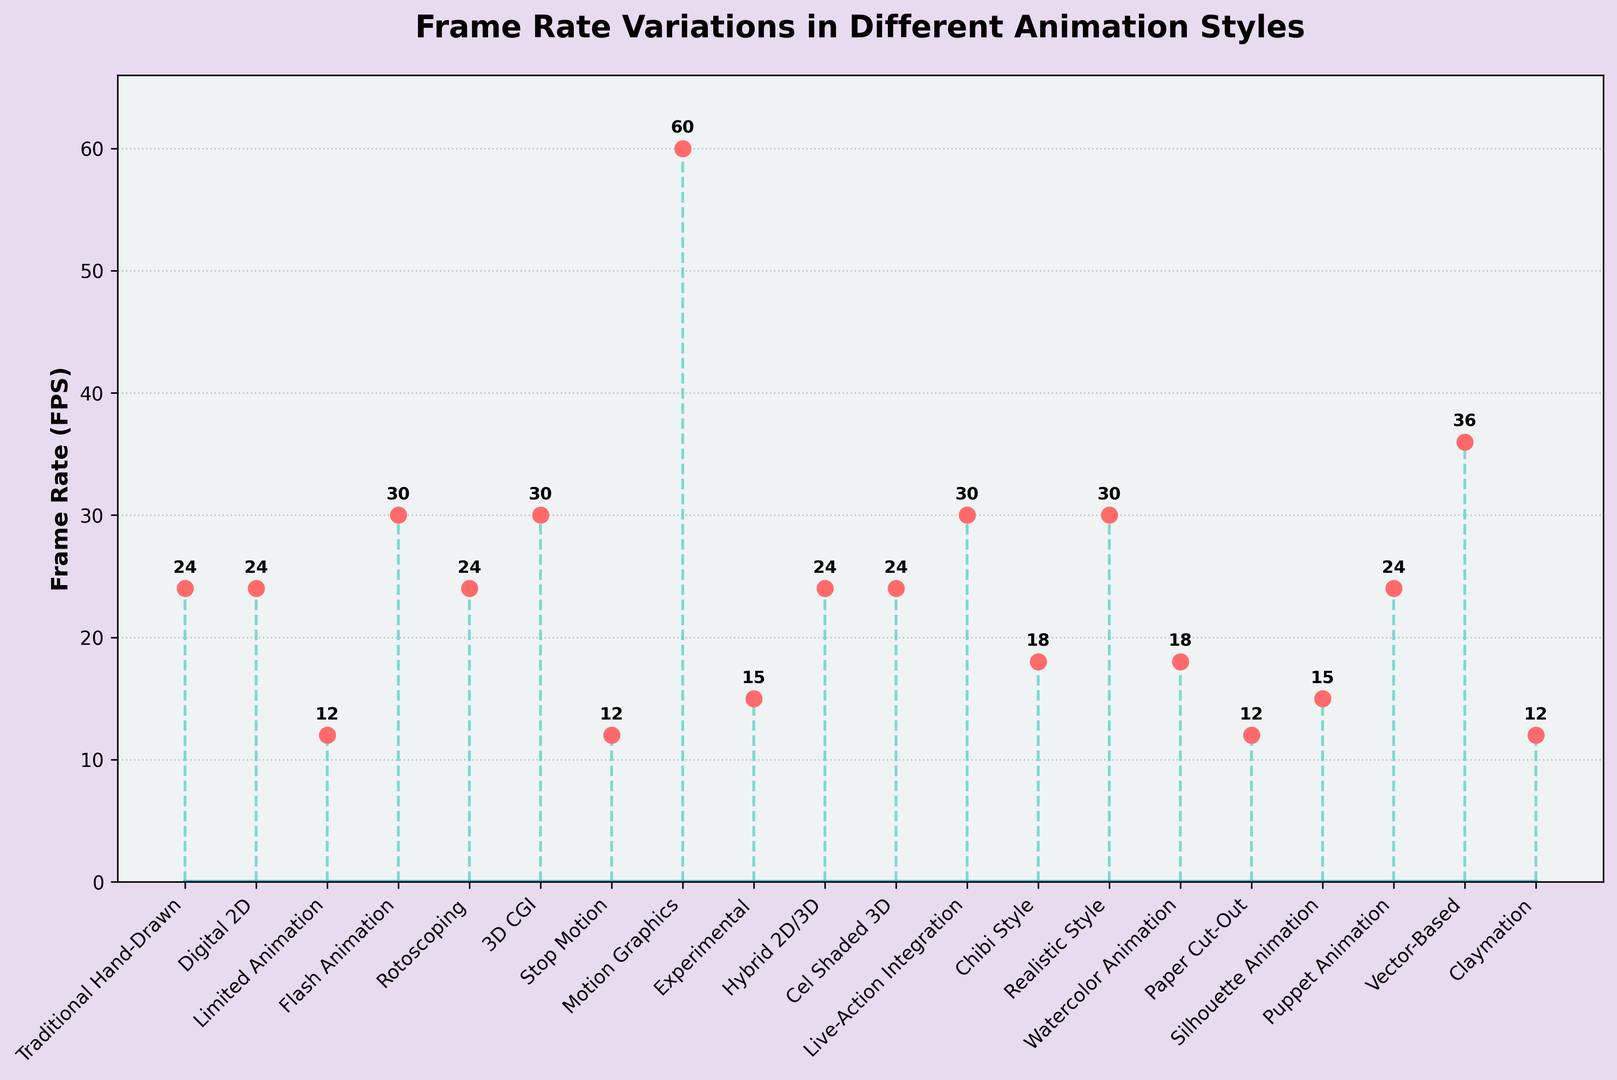What animation style has the highest frame rate? To determine the highest frame rate, observe the tallest stem in the plot that reaches the highest value on the y-axis. The style labeled "Motion Graphics" reaches 60 FPS.
Answer: Motion Graphics Which animation styles have a frame rate of 30 FPS? Look for stems that reach the 30 FPS mark on the y-axis. The labels at these points are "Flash Animation", "3D CGI", "Live-Action Integration", and "Realistic Style".
Answer: Flash Animation, 3D CGI, Live-Action Integration, Realistic Style How many animation styles have a frame rate less than 20 FPS? Count the number of stems that do not reach the 20 FPS mark on the y-axis. The styles are "Limited Animation" (12 FPS), "Stop Motion" (12 FPS), "Paper Cut-Out" (12 FPS), "Claymation" (12 FPS), "Experimental" (15 FPS), and "Silhouette Animation" (15 FPS). There are 6 in total.
Answer: 6 What is the difference in frame rate between "Vector-Based" and "Chibi Style"? The frame rate of "Vector-Based" is 36 FPS and "Chibi Style" is 18 FPS. The difference is calculated as 36 - 18 = 18 FPS.
Answer: 18 FPS What is the average frame rate of traditional and digital 2D animation styles (Traditional Hand-Drawn and Digital 2D)? Both styles have a frame rate of 24 FPS. The average is calculated as (24 + 24) / 2 = 24 FPS.
Answer: 24 FPS Which animation style is represented by the darkest stem lines in the plot? The stems are visually unified by color so this question is not applicable, but if we interpret "darkest" as "most visually emphasized", we would appreciate the lengths of the stems because the highest would get more visual attention. The longest stems, hence most darkly highlighted (tallest), are "Motion Graphics".
Answer: Motion Graphics Is the frame rate of "Watercolor Animation" higher or lower than "Limited Animation"? The frame rate of "Watercolor Animation" is 18 FPS, and "Limited Animation" is 12 FPS. Comparing these values shows 18 FPS (Watercolor Animation) is higher than 12 FPS (Limited Animation).
Answer: Higher Which animation styles have a frame rate equal to 24 FPS? Look for stems reaching the 24 FPS mark. The labels are "Traditional Hand-Drawn", "Digital 2D", "Rotoscoping", "Hybrid 2D/3D", "Cel Shaded 3D", and "Puppet Animation".
Answer: Traditional Hand-Drawn, Digital 2D, Rotoscoping, Hybrid 2D/3D, Cel Shaded 3D, Puppet Animation 